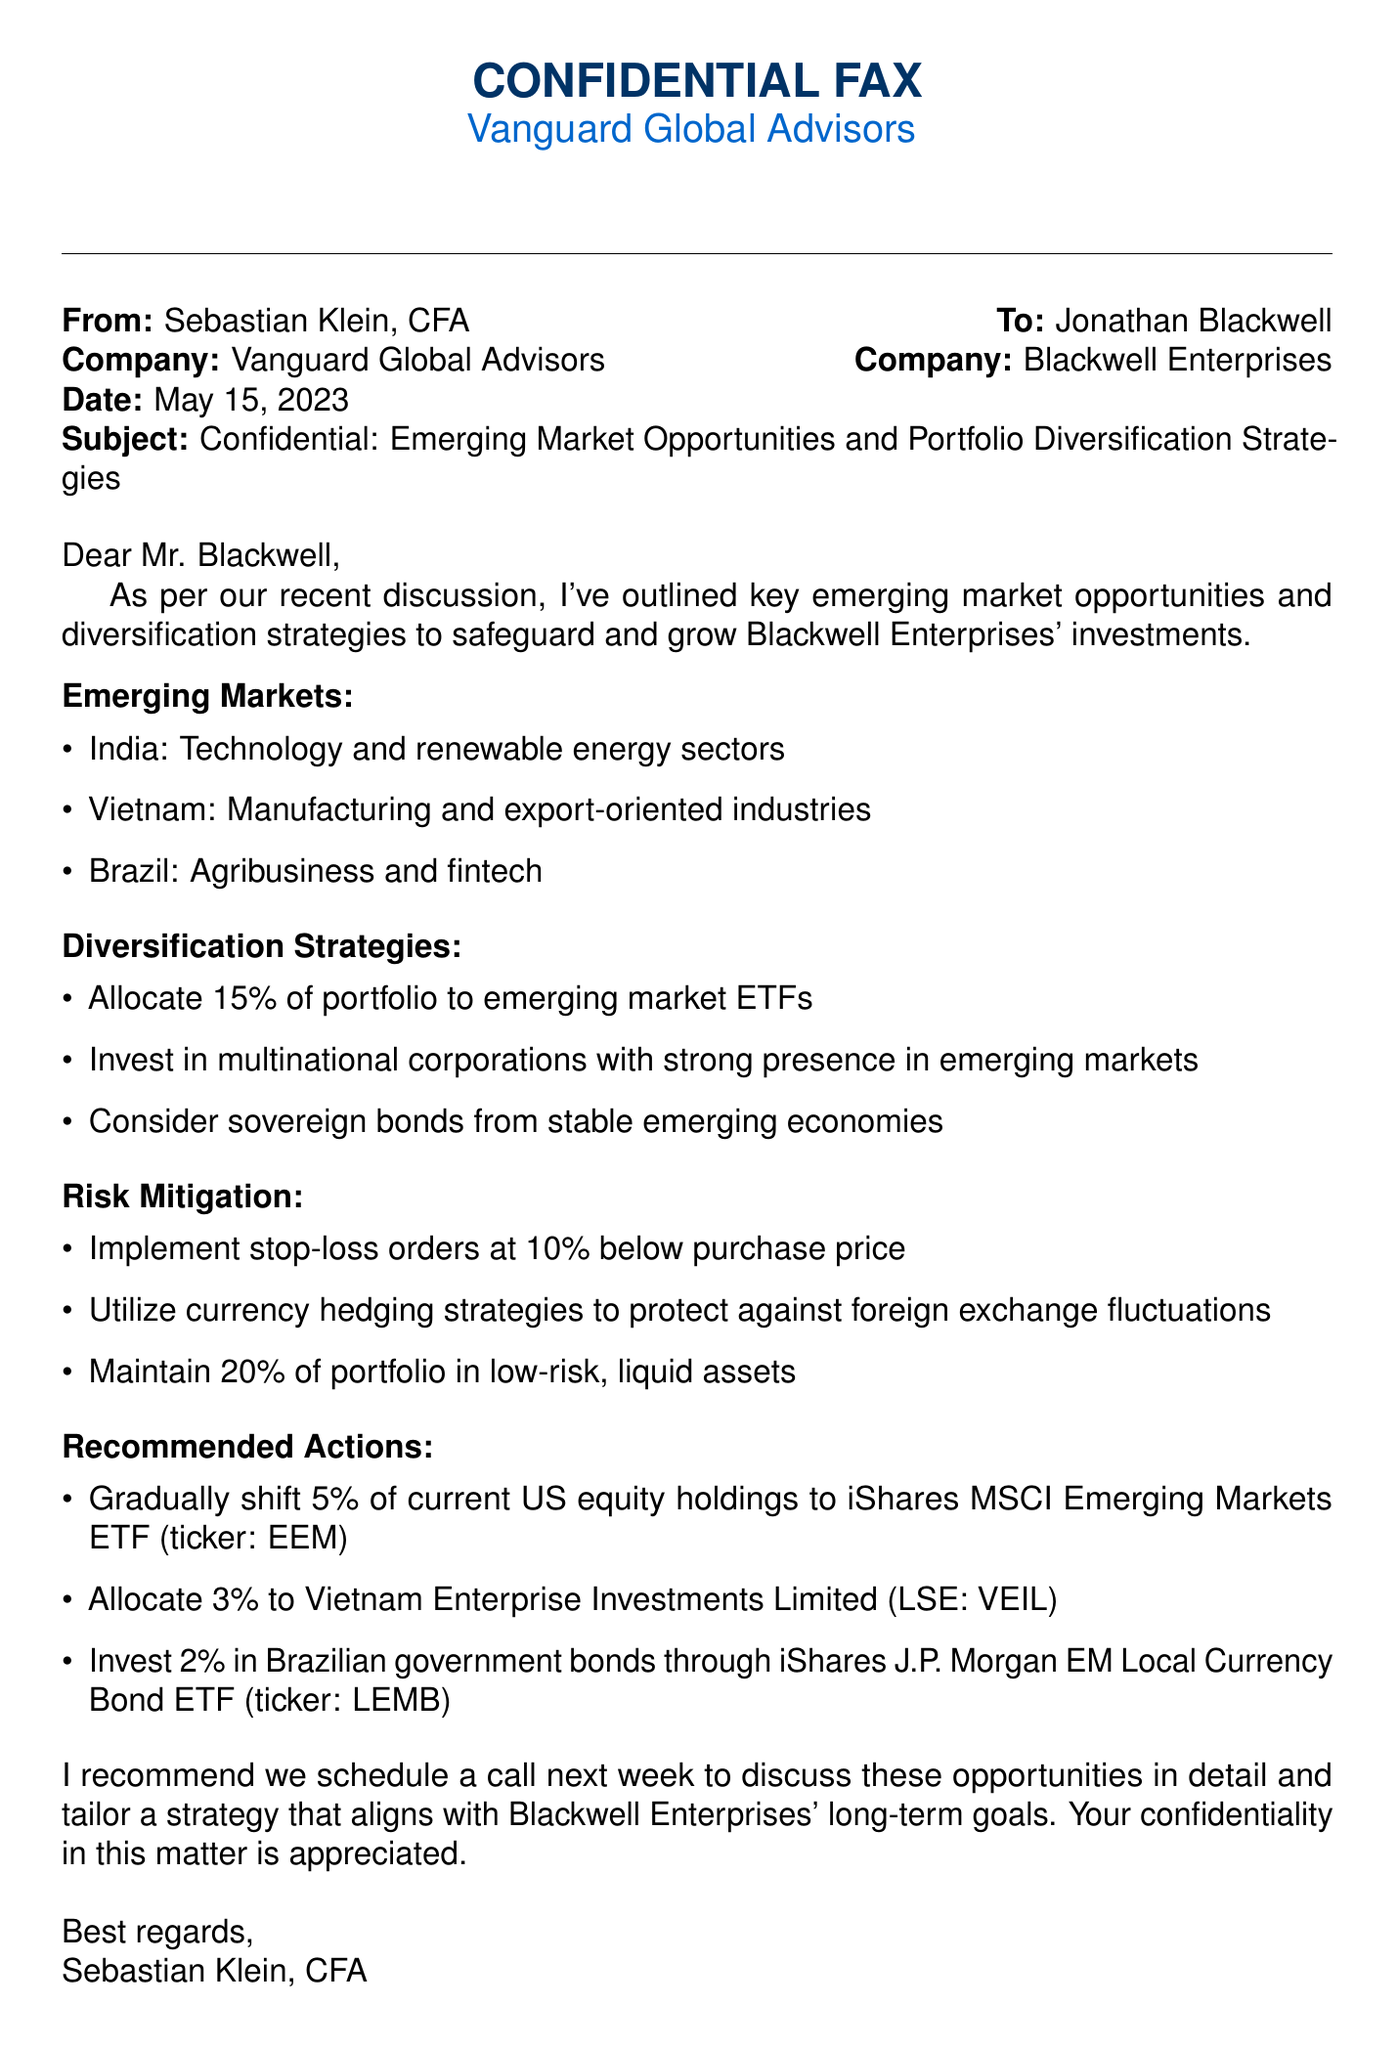What is the date of the fax? The date of the fax is mentioned at the top of the document.
Answer: May 15, 2023 Who is the sender of the fax? The sender's name is listed after "From:" in the document.
Answer: Sebastian Klein, CFA What percentage of the portfolio is recommended to allocate to emerging market ETFs? The specific percentage for allocation is found in the diversification strategies section.
Answer: 15% Which country's technology and renewable energy sectors are mentioned as opportunities? The document lists countries and their respective sectors in the emerging markets section.
Answer: India What is one of the risk mitigation strategies mentioned? The document lists multiple strategies under the risk mitigation section.
Answer: Implement stop-loss orders at 10% below purchase price What is the ticker for the iShares MSCI Emerging Markets ETF? The ticker is provided next to the recommended actions for investments.
Answer: EEM What percentage of holdings is suggested to shift to emerging markets gradually? The gradual shift percentage is specified in the recommended actions section.
Answer: 5% Which financial advisor company is mentioned in the fax? The company name appears in the header of the document.
Answer: Vanguard Global Advisors What is the subject of the fax? The subject is stated clearly underneath the date.
Answer: Confidential: Emerging Market Opportunities and Portfolio Diversification Strategies 